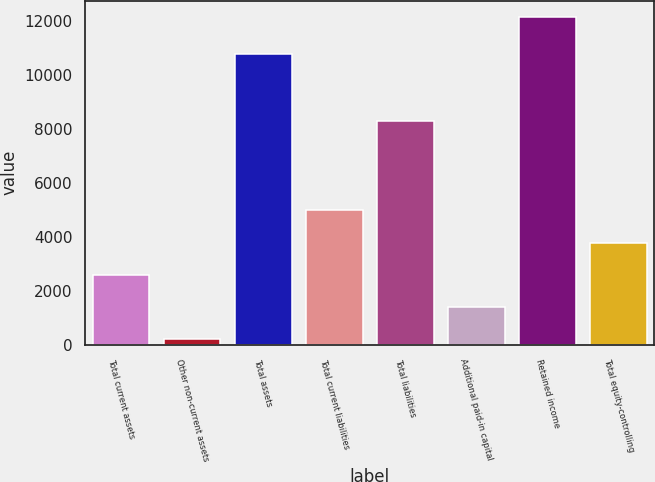Convert chart. <chart><loc_0><loc_0><loc_500><loc_500><bar_chart><fcel>Total current assets<fcel>Other non-current assets<fcel>Total assets<fcel>Total current liabilities<fcel>Total liabilities<fcel>Additional paid-in capital<fcel>Retained income<fcel>Total equity-controlling<nl><fcel>2603.2<fcel>215<fcel>10795<fcel>4991.4<fcel>8314<fcel>1409.1<fcel>12156<fcel>3797.3<nl></chart> 